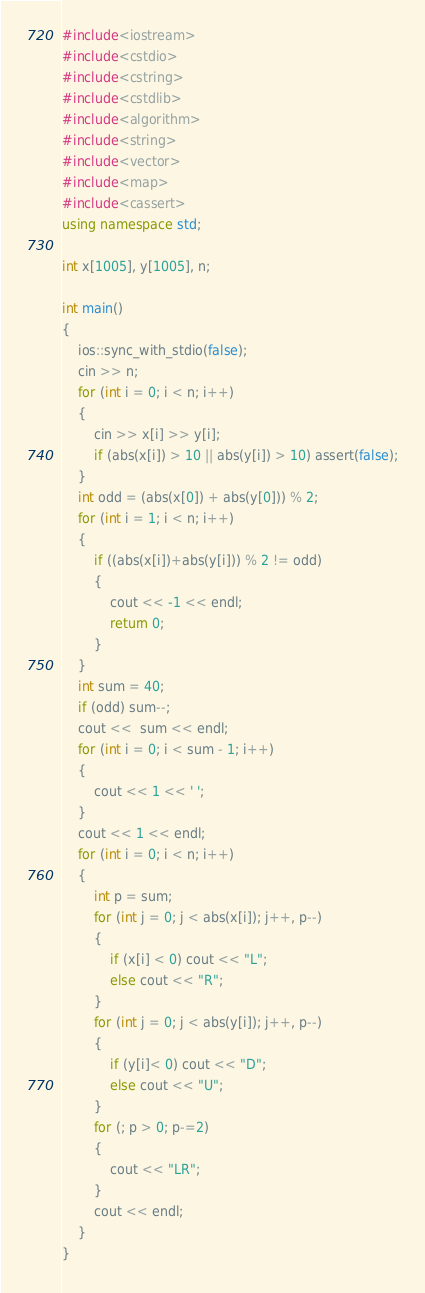Convert code to text. <code><loc_0><loc_0><loc_500><loc_500><_C++_>#include<iostream>
#include<cstdio>
#include<cstring>
#include<cstdlib>
#include<algorithm>
#include<string>
#include<vector>
#include<map>
#include<cassert>
using namespace std;

int x[1005], y[1005], n;

int main()
{
    ios::sync_with_stdio(false);
    cin >> n;
    for (int i = 0; i < n; i++)
    {
        cin >> x[i] >> y[i];
        if (abs(x[i]) > 10 || abs(y[i]) > 10) assert(false);
    }
    int odd = (abs(x[0]) + abs(y[0])) % 2;
    for (int i = 1; i < n; i++)
    {
        if ((abs(x[i])+abs(y[i])) % 2 != odd)
        {
            cout << -1 << endl;
            return 0;
        }
    }
    int sum = 40;
    if (odd) sum--;
    cout <<  sum << endl;
    for (int i = 0; i < sum - 1; i++)
    {
        cout << 1 << ' ';
    }
    cout << 1 << endl;
    for (int i = 0; i < n; i++)
    {
        int p = sum;
        for (int j = 0; j < abs(x[i]); j++, p--)
        {
            if (x[i] < 0) cout << "L";
            else cout << "R";
        }
        for (int j = 0; j < abs(y[i]); j++, p--)
        {
            if (y[i]< 0) cout << "D";
            else cout << "U";
        }
        for (; p > 0; p-=2)
        {
            cout << "LR";
        }
        cout << endl;
    }
}</code> 